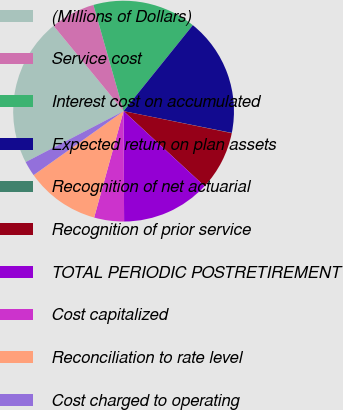Convert chart. <chart><loc_0><loc_0><loc_500><loc_500><pie_chart><fcel>(Millions of Dollars)<fcel>Service cost<fcel>Interest cost on accumulated<fcel>Expected return on plan assets<fcel>Recognition of net actuarial<fcel>Recognition of prior service<fcel>TOTAL PERIODIC POSTRETIREMENT<fcel>Cost capitalized<fcel>Reconciliation to rate level<fcel>Cost charged to operating<nl><fcel>21.7%<fcel>6.53%<fcel>15.2%<fcel>17.37%<fcel>0.03%<fcel>8.7%<fcel>13.03%<fcel>4.37%<fcel>10.87%<fcel>2.2%<nl></chart> 